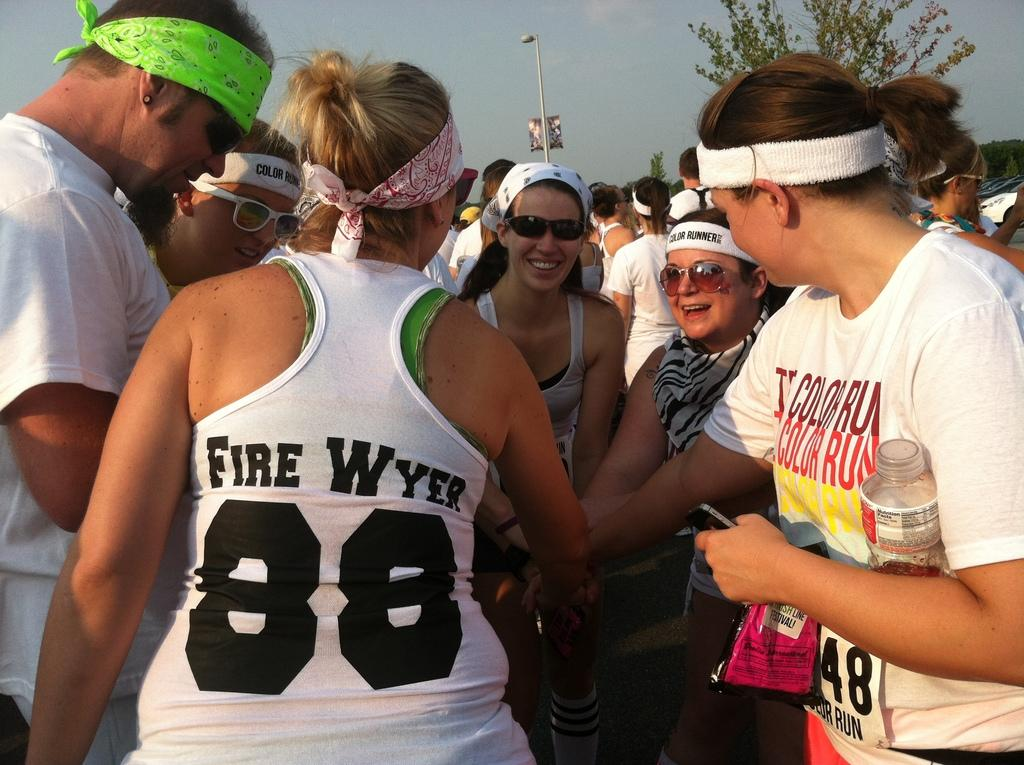<image>
Describe the image concisely. the lady wearing Fire Wyer 88 top is cheering with others 